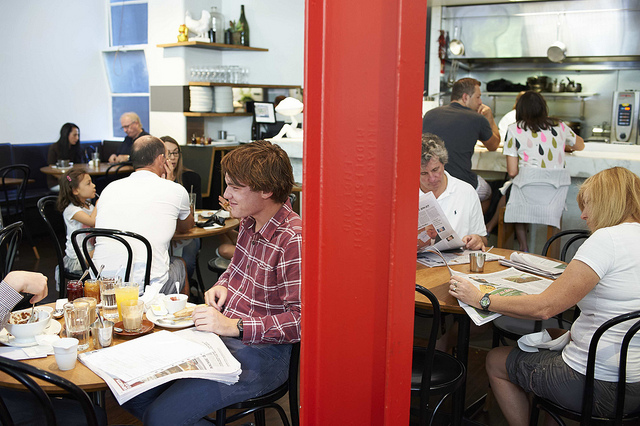What does the interior of this place suggest about the type of establishment it is? The interior features a casual and cozy setup with simple décor, which hints at it being a local café or bistro where people come to enjoy light meals, beverages, and perhaps to read or meet friends. 